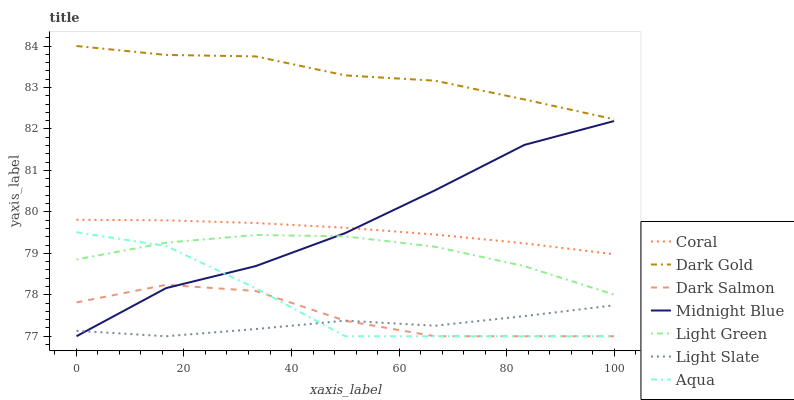Does Light Slate have the minimum area under the curve?
Answer yes or no. Yes. Does Dark Gold have the maximum area under the curve?
Answer yes or no. Yes. Does Dark Gold have the minimum area under the curve?
Answer yes or no. No. Does Light Slate have the maximum area under the curve?
Answer yes or no. No. Is Coral the smoothest?
Answer yes or no. Yes. Is Aqua the roughest?
Answer yes or no. Yes. Is Dark Gold the smoothest?
Answer yes or no. No. Is Dark Gold the roughest?
Answer yes or no. No. Does Midnight Blue have the lowest value?
Answer yes or no. Yes. Does Dark Gold have the lowest value?
Answer yes or no. No. Does Dark Gold have the highest value?
Answer yes or no. Yes. Does Light Slate have the highest value?
Answer yes or no. No. Is Aqua less than Coral?
Answer yes or no. Yes. Is Dark Gold greater than Midnight Blue?
Answer yes or no. Yes. Does Aqua intersect Light Slate?
Answer yes or no. Yes. Is Aqua less than Light Slate?
Answer yes or no. No. Is Aqua greater than Light Slate?
Answer yes or no. No. Does Aqua intersect Coral?
Answer yes or no. No. 